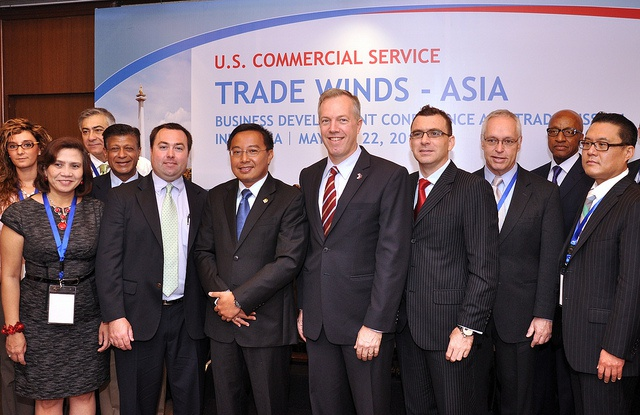Describe the objects in this image and their specific colors. I can see people in black and salmon tones, people in black, lavender, salmon, and brown tones, people in black, maroon, brown, and lavender tones, people in black, maroon, gray, and brown tones, and people in black, salmon, and brown tones in this image. 